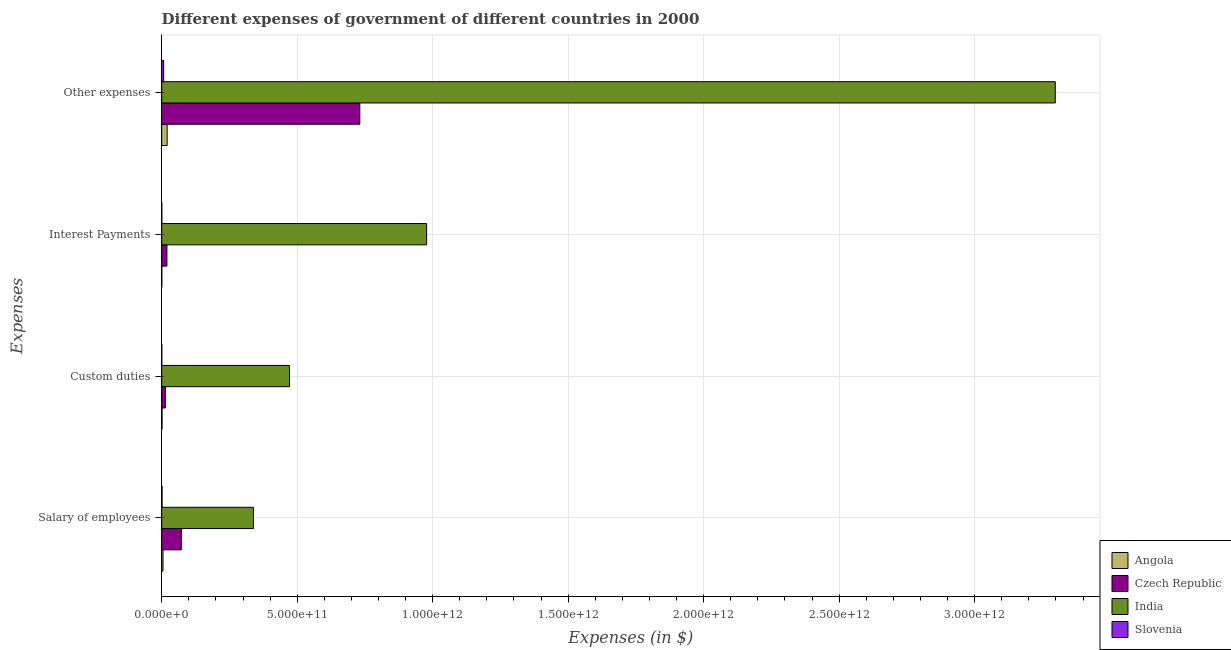How many bars are there on the 2nd tick from the top?
Provide a succinct answer. 4. How many bars are there on the 1st tick from the bottom?
Ensure brevity in your answer.  4. What is the label of the 4th group of bars from the top?
Keep it short and to the point. Salary of employees. What is the amount spent on salary of employees in India?
Provide a succinct answer. 3.39e+11. Across all countries, what is the maximum amount spent on interest payments?
Offer a very short reply. 9.78e+11. Across all countries, what is the minimum amount spent on interest payments?
Provide a succinct answer. 1.75e+08. In which country was the amount spent on salary of employees maximum?
Your response must be concise. India. In which country was the amount spent on salary of employees minimum?
Your answer should be compact. Slovenia. What is the total amount spent on interest payments in the graph?
Your answer should be very brief. 9.97e+11. What is the difference between the amount spent on salary of employees in Slovenia and that in India?
Your response must be concise. -3.37e+11. What is the difference between the amount spent on interest payments in Slovenia and the amount spent on other expenses in Angola?
Your answer should be compact. -1.98e+1. What is the average amount spent on salary of employees per country?
Give a very brief answer. 1.04e+11. What is the difference between the amount spent on interest payments and amount spent on other expenses in Angola?
Your response must be concise. -1.99e+1. In how many countries, is the amount spent on custom duties greater than 1500000000000 $?
Give a very brief answer. 0. What is the ratio of the amount spent on interest payments in Angola to that in India?
Your answer should be very brief. 0. Is the amount spent on custom duties in India less than that in Angola?
Your answer should be very brief. No. Is the difference between the amount spent on custom duties in Czech Republic and Slovenia greater than the difference between the amount spent on interest payments in Czech Republic and Slovenia?
Your answer should be very brief. No. What is the difference between the highest and the second highest amount spent on interest payments?
Provide a short and direct response. 9.59e+11. What is the difference between the highest and the lowest amount spent on interest payments?
Offer a terse response. 9.78e+11. In how many countries, is the amount spent on other expenses greater than the average amount spent on other expenses taken over all countries?
Your response must be concise. 1. Is the sum of the amount spent on salary of employees in Angola and Czech Republic greater than the maximum amount spent on custom duties across all countries?
Make the answer very short. No. What does the 1st bar from the top in Custom duties represents?
Offer a very short reply. Slovenia. What does the 3rd bar from the bottom in Salary of employees represents?
Your response must be concise. India. Is it the case that in every country, the sum of the amount spent on salary of employees and amount spent on custom duties is greater than the amount spent on interest payments?
Your answer should be very brief. No. How many bars are there?
Make the answer very short. 16. How many countries are there in the graph?
Give a very brief answer. 4. What is the difference between two consecutive major ticks on the X-axis?
Give a very brief answer. 5.00e+11. Does the graph contain grids?
Provide a short and direct response. Yes. Where does the legend appear in the graph?
Offer a terse response. Bottom right. What is the title of the graph?
Ensure brevity in your answer.  Different expenses of government of different countries in 2000. What is the label or title of the X-axis?
Make the answer very short. Expenses (in $). What is the label or title of the Y-axis?
Offer a very short reply. Expenses. What is the Expenses (in $) in Angola in Salary of employees?
Provide a short and direct response. 4.77e+09. What is the Expenses (in $) of Czech Republic in Salary of employees?
Offer a terse response. 7.26e+1. What is the Expenses (in $) in India in Salary of employees?
Your response must be concise. 3.39e+11. What is the Expenses (in $) in Slovenia in Salary of employees?
Your response must be concise. 1.30e+09. What is the Expenses (in $) of Angola in Custom duties?
Offer a very short reply. 1.20e+09. What is the Expenses (in $) of Czech Republic in Custom duties?
Offer a very short reply. 1.36e+1. What is the Expenses (in $) in India in Custom duties?
Your answer should be very brief. 4.72e+11. What is the Expenses (in $) in Slovenia in Custom duties?
Offer a terse response. 1.59e+08. What is the Expenses (in $) in Angola in Interest Payments?
Give a very brief answer. 1.75e+08. What is the Expenses (in $) of Czech Republic in Interest Payments?
Make the answer very short. 1.92e+1. What is the Expenses (in $) of India in Interest Payments?
Offer a terse response. 9.78e+11. What is the Expenses (in $) of Slovenia in Interest Payments?
Give a very brief answer. 2.54e+08. What is the Expenses (in $) in Angola in Other expenses?
Your response must be concise. 2.00e+1. What is the Expenses (in $) of Czech Republic in Other expenses?
Give a very brief answer. 7.31e+11. What is the Expenses (in $) of India in Other expenses?
Your response must be concise. 3.30e+12. What is the Expenses (in $) in Slovenia in Other expenses?
Provide a short and direct response. 7.21e+09. Across all Expenses, what is the maximum Expenses (in $) in Angola?
Ensure brevity in your answer.  2.00e+1. Across all Expenses, what is the maximum Expenses (in $) of Czech Republic?
Give a very brief answer. 7.31e+11. Across all Expenses, what is the maximum Expenses (in $) of India?
Make the answer very short. 3.30e+12. Across all Expenses, what is the maximum Expenses (in $) of Slovenia?
Your answer should be very brief. 7.21e+09. Across all Expenses, what is the minimum Expenses (in $) in Angola?
Provide a short and direct response. 1.75e+08. Across all Expenses, what is the minimum Expenses (in $) of Czech Republic?
Make the answer very short. 1.36e+1. Across all Expenses, what is the minimum Expenses (in $) in India?
Provide a short and direct response. 3.39e+11. Across all Expenses, what is the minimum Expenses (in $) in Slovenia?
Offer a terse response. 1.59e+08. What is the total Expenses (in $) in Angola in the graph?
Provide a succinct answer. 2.62e+1. What is the total Expenses (in $) of Czech Republic in the graph?
Your answer should be compact. 8.36e+11. What is the total Expenses (in $) of India in the graph?
Ensure brevity in your answer.  5.09e+12. What is the total Expenses (in $) in Slovenia in the graph?
Your answer should be very brief. 8.92e+09. What is the difference between the Expenses (in $) in Angola in Salary of employees and that in Custom duties?
Provide a short and direct response. 3.57e+09. What is the difference between the Expenses (in $) in Czech Republic in Salary of employees and that in Custom duties?
Ensure brevity in your answer.  5.89e+1. What is the difference between the Expenses (in $) of India in Salary of employees and that in Custom duties?
Your answer should be compact. -1.33e+11. What is the difference between the Expenses (in $) in Slovenia in Salary of employees and that in Custom duties?
Make the answer very short. 1.14e+09. What is the difference between the Expenses (in $) of Angola in Salary of employees and that in Interest Payments?
Your answer should be very brief. 4.60e+09. What is the difference between the Expenses (in $) in Czech Republic in Salary of employees and that in Interest Payments?
Offer a very short reply. 5.34e+1. What is the difference between the Expenses (in $) of India in Salary of employees and that in Interest Payments?
Offer a very short reply. -6.39e+11. What is the difference between the Expenses (in $) of Slovenia in Salary of employees and that in Interest Payments?
Provide a short and direct response. 1.04e+09. What is the difference between the Expenses (in $) of Angola in Salary of employees and that in Other expenses?
Your response must be concise. -1.53e+1. What is the difference between the Expenses (in $) in Czech Republic in Salary of employees and that in Other expenses?
Keep it short and to the point. -6.59e+11. What is the difference between the Expenses (in $) of India in Salary of employees and that in Other expenses?
Offer a very short reply. -2.96e+12. What is the difference between the Expenses (in $) of Slovenia in Salary of employees and that in Other expenses?
Ensure brevity in your answer.  -5.91e+09. What is the difference between the Expenses (in $) in Angola in Custom duties and that in Interest Payments?
Offer a terse response. 1.03e+09. What is the difference between the Expenses (in $) of Czech Republic in Custom duties and that in Interest Payments?
Provide a short and direct response. -5.54e+09. What is the difference between the Expenses (in $) in India in Custom duties and that in Interest Payments?
Offer a very short reply. -5.06e+11. What is the difference between the Expenses (in $) in Slovenia in Custom duties and that in Interest Payments?
Provide a succinct answer. -9.51e+07. What is the difference between the Expenses (in $) of Angola in Custom duties and that in Other expenses?
Your answer should be very brief. -1.88e+1. What is the difference between the Expenses (in $) of Czech Republic in Custom duties and that in Other expenses?
Offer a very short reply. -7.17e+11. What is the difference between the Expenses (in $) of India in Custom duties and that in Other expenses?
Give a very brief answer. -2.83e+12. What is the difference between the Expenses (in $) in Slovenia in Custom duties and that in Other expenses?
Ensure brevity in your answer.  -7.05e+09. What is the difference between the Expenses (in $) of Angola in Interest Payments and that in Other expenses?
Offer a terse response. -1.99e+1. What is the difference between the Expenses (in $) in Czech Republic in Interest Payments and that in Other expenses?
Give a very brief answer. -7.12e+11. What is the difference between the Expenses (in $) of India in Interest Payments and that in Other expenses?
Keep it short and to the point. -2.32e+12. What is the difference between the Expenses (in $) of Slovenia in Interest Payments and that in Other expenses?
Your response must be concise. -6.96e+09. What is the difference between the Expenses (in $) in Angola in Salary of employees and the Expenses (in $) in Czech Republic in Custom duties?
Keep it short and to the point. -8.84e+09. What is the difference between the Expenses (in $) of Angola in Salary of employees and the Expenses (in $) of India in Custom duties?
Your answer should be compact. -4.67e+11. What is the difference between the Expenses (in $) in Angola in Salary of employees and the Expenses (in $) in Slovenia in Custom duties?
Provide a short and direct response. 4.62e+09. What is the difference between the Expenses (in $) in Czech Republic in Salary of employees and the Expenses (in $) in India in Custom duties?
Offer a terse response. -3.99e+11. What is the difference between the Expenses (in $) of Czech Republic in Salary of employees and the Expenses (in $) of Slovenia in Custom duties?
Ensure brevity in your answer.  7.24e+1. What is the difference between the Expenses (in $) in India in Salary of employees and the Expenses (in $) in Slovenia in Custom duties?
Your response must be concise. 3.38e+11. What is the difference between the Expenses (in $) in Angola in Salary of employees and the Expenses (in $) in Czech Republic in Interest Payments?
Ensure brevity in your answer.  -1.44e+1. What is the difference between the Expenses (in $) of Angola in Salary of employees and the Expenses (in $) of India in Interest Payments?
Provide a short and direct response. -9.73e+11. What is the difference between the Expenses (in $) of Angola in Salary of employees and the Expenses (in $) of Slovenia in Interest Payments?
Provide a short and direct response. 4.52e+09. What is the difference between the Expenses (in $) of Czech Republic in Salary of employees and the Expenses (in $) of India in Interest Payments?
Your response must be concise. -9.05e+11. What is the difference between the Expenses (in $) of Czech Republic in Salary of employees and the Expenses (in $) of Slovenia in Interest Payments?
Provide a succinct answer. 7.23e+1. What is the difference between the Expenses (in $) in India in Salary of employees and the Expenses (in $) in Slovenia in Interest Payments?
Give a very brief answer. 3.38e+11. What is the difference between the Expenses (in $) of Angola in Salary of employees and the Expenses (in $) of Czech Republic in Other expenses?
Give a very brief answer. -7.26e+11. What is the difference between the Expenses (in $) of Angola in Salary of employees and the Expenses (in $) of India in Other expenses?
Provide a short and direct response. -3.29e+12. What is the difference between the Expenses (in $) in Angola in Salary of employees and the Expenses (in $) in Slovenia in Other expenses?
Provide a short and direct response. -2.44e+09. What is the difference between the Expenses (in $) in Czech Republic in Salary of employees and the Expenses (in $) in India in Other expenses?
Offer a terse response. -3.23e+12. What is the difference between the Expenses (in $) in Czech Republic in Salary of employees and the Expenses (in $) in Slovenia in Other expenses?
Ensure brevity in your answer.  6.53e+1. What is the difference between the Expenses (in $) in India in Salary of employees and the Expenses (in $) in Slovenia in Other expenses?
Your answer should be compact. 3.31e+11. What is the difference between the Expenses (in $) of Angola in Custom duties and the Expenses (in $) of Czech Republic in Interest Payments?
Keep it short and to the point. -1.79e+1. What is the difference between the Expenses (in $) of Angola in Custom duties and the Expenses (in $) of India in Interest Payments?
Provide a succinct answer. -9.76e+11. What is the difference between the Expenses (in $) in Angola in Custom duties and the Expenses (in $) in Slovenia in Interest Payments?
Offer a terse response. 9.49e+08. What is the difference between the Expenses (in $) of Czech Republic in Custom duties and the Expenses (in $) of India in Interest Payments?
Provide a short and direct response. -9.64e+11. What is the difference between the Expenses (in $) of Czech Republic in Custom duties and the Expenses (in $) of Slovenia in Interest Payments?
Make the answer very short. 1.34e+1. What is the difference between the Expenses (in $) in India in Custom duties and the Expenses (in $) in Slovenia in Interest Payments?
Offer a very short reply. 4.71e+11. What is the difference between the Expenses (in $) of Angola in Custom duties and the Expenses (in $) of Czech Republic in Other expenses?
Give a very brief answer. -7.30e+11. What is the difference between the Expenses (in $) of Angola in Custom duties and the Expenses (in $) of India in Other expenses?
Make the answer very short. -3.30e+12. What is the difference between the Expenses (in $) of Angola in Custom duties and the Expenses (in $) of Slovenia in Other expenses?
Offer a terse response. -6.01e+09. What is the difference between the Expenses (in $) in Czech Republic in Custom duties and the Expenses (in $) in India in Other expenses?
Offer a terse response. -3.28e+12. What is the difference between the Expenses (in $) in Czech Republic in Custom duties and the Expenses (in $) in Slovenia in Other expenses?
Offer a very short reply. 6.40e+09. What is the difference between the Expenses (in $) of India in Custom duties and the Expenses (in $) of Slovenia in Other expenses?
Offer a very short reply. 4.65e+11. What is the difference between the Expenses (in $) in Angola in Interest Payments and the Expenses (in $) in Czech Republic in Other expenses?
Provide a short and direct response. -7.31e+11. What is the difference between the Expenses (in $) in Angola in Interest Payments and the Expenses (in $) in India in Other expenses?
Offer a terse response. -3.30e+12. What is the difference between the Expenses (in $) in Angola in Interest Payments and the Expenses (in $) in Slovenia in Other expenses?
Your answer should be very brief. -7.04e+09. What is the difference between the Expenses (in $) in Czech Republic in Interest Payments and the Expenses (in $) in India in Other expenses?
Your response must be concise. -3.28e+12. What is the difference between the Expenses (in $) of Czech Republic in Interest Payments and the Expenses (in $) of Slovenia in Other expenses?
Offer a terse response. 1.19e+1. What is the difference between the Expenses (in $) of India in Interest Payments and the Expenses (in $) of Slovenia in Other expenses?
Your answer should be compact. 9.70e+11. What is the average Expenses (in $) of Angola per Expenses?
Make the answer very short. 6.55e+09. What is the average Expenses (in $) in Czech Republic per Expenses?
Your answer should be compact. 2.09e+11. What is the average Expenses (in $) in India per Expenses?
Your response must be concise. 1.27e+12. What is the average Expenses (in $) of Slovenia per Expenses?
Keep it short and to the point. 2.23e+09. What is the difference between the Expenses (in $) in Angola and Expenses (in $) in Czech Republic in Salary of employees?
Offer a terse response. -6.78e+1. What is the difference between the Expenses (in $) of Angola and Expenses (in $) of India in Salary of employees?
Keep it short and to the point. -3.34e+11. What is the difference between the Expenses (in $) of Angola and Expenses (in $) of Slovenia in Salary of employees?
Provide a short and direct response. 3.48e+09. What is the difference between the Expenses (in $) in Czech Republic and Expenses (in $) in India in Salary of employees?
Your response must be concise. -2.66e+11. What is the difference between the Expenses (in $) in Czech Republic and Expenses (in $) in Slovenia in Salary of employees?
Ensure brevity in your answer.  7.13e+1. What is the difference between the Expenses (in $) of India and Expenses (in $) of Slovenia in Salary of employees?
Your answer should be very brief. 3.37e+11. What is the difference between the Expenses (in $) in Angola and Expenses (in $) in Czech Republic in Custom duties?
Your answer should be very brief. -1.24e+1. What is the difference between the Expenses (in $) of Angola and Expenses (in $) of India in Custom duties?
Offer a very short reply. -4.71e+11. What is the difference between the Expenses (in $) in Angola and Expenses (in $) in Slovenia in Custom duties?
Your response must be concise. 1.04e+09. What is the difference between the Expenses (in $) of Czech Republic and Expenses (in $) of India in Custom duties?
Provide a succinct answer. -4.58e+11. What is the difference between the Expenses (in $) in Czech Republic and Expenses (in $) in Slovenia in Custom duties?
Provide a short and direct response. 1.35e+1. What is the difference between the Expenses (in $) in India and Expenses (in $) in Slovenia in Custom duties?
Make the answer very short. 4.72e+11. What is the difference between the Expenses (in $) of Angola and Expenses (in $) of Czech Republic in Interest Payments?
Ensure brevity in your answer.  -1.90e+1. What is the difference between the Expenses (in $) in Angola and Expenses (in $) in India in Interest Payments?
Your response must be concise. -9.78e+11. What is the difference between the Expenses (in $) in Angola and Expenses (in $) in Slovenia in Interest Payments?
Give a very brief answer. -7.95e+07. What is the difference between the Expenses (in $) of Czech Republic and Expenses (in $) of India in Interest Payments?
Your answer should be compact. -9.59e+11. What is the difference between the Expenses (in $) of Czech Republic and Expenses (in $) of Slovenia in Interest Payments?
Make the answer very short. 1.89e+1. What is the difference between the Expenses (in $) in India and Expenses (in $) in Slovenia in Interest Payments?
Offer a very short reply. 9.77e+11. What is the difference between the Expenses (in $) of Angola and Expenses (in $) of Czech Republic in Other expenses?
Keep it short and to the point. -7.11e+11. What is the difference between the Expenses (in $) of Angola and Expenses (in $) of India in Other expenses?
Your response must be concise. -3.28e+12. What is the difference between the Expenses (in $) in Angola and Expenses (in $) in Slovenia in Other expenses?
Offer a very short reply. 1.28e+1. What is the difference between the Expenses (in $) in Czech Republic and Expenses (in $) in India in Other expenses?
Keep it short and to the point. -2.57e+12. What is the difference between the Expenses (in $) of Czech Republic and Expenses (in $) of Slovenia in Other expenses?
Provide a succinct answer. 7.24e+11. What is the difference between the Expenses (in $) in India and Expenses (in $) in Slovenia in Other expenses?
Provide a succinct answer. 3.29e+12. What is the ratio of the Expenses (in $) of Angola in Salary of employees to that in Custom duties?
Offer a very short reply. 3.97. What is the ratio of the Expenses (in $) of Czech Republic in Salary of employees to that in Custom duties?
Your response must be concise. 5.33. What is the ratio of the Expenses (in $) in India in Salary of employees to that in Custom duties?
Ensure brevity in your answer.  0.72. What is the ratio of the Expenses (in $) in Slovenia in Salary of employees to that in Custom duties?
Make the answer very short. 8.16. What is the ratio of the Expenses (in $) of Angola in Salary of employees to that in Interest Payments?
Ensure brevity in your answer.  27.35. What is the ratio of the Expenses (in $) in Czech Republic in Salary of employees to that in Interest Payments?
Make the answer very short. 3.79. What is the ratio of the Expenses (in $) of India in Salary of employees to that in Interest Payments?
Offer a terse response. 0.35. What is the ratio of the Expenses (in $) in Slovenia in Salary of employees to that in Interest Payments?
Provide a succinct answer. 5.11. What is the ratio of the Expenses (in $) in Angola in Salary of employees to that in Other expenses?
Offer a very short reply. 0.24. What is the ratio of the Expenses (in $) in Czech Republic in Salary of employees to that in Other expenses?
Your response must be concise. 0.1. What is the ratio of the Expenses (in $) in India in Salary of employees to that in Other expenses?
Keep it short and to the point. 0.1. What is the ratio of the Expenses (in $) of Slovenia in Salary of employees to that in Other expenses?
Your answer should be compact. 0.18. What is the ratio of the Expenses (in $) of Angola in Custom duties to that in Interest Payments?
Provide a short and direct response. 6.89. What is the ratio of the Expenses (in $) of Czech Republic in Custom duties to that in Interest Payments?
Ensure brevity in your answer.  0.71. What is the ratio of the Expenses (in $) in India in Custom duties to that in Interest Payments?
Your answer should be compact. 0.48. What is the ratio of the Expenses (in $) in Slovenia in Custom duties to that in Interest Payments?
Make the answer very short. 0.63. What is the ratio of the Expenses (in $) in Angola in Custom duties to that in Other expenses?
Provide a succinct answer. 0.06. What is the ratio of the Expenses (in $) in Czech Republic in Custom duties to that in Other expenses?
Ensure brevity in your answer.  0.02. What is the ratio of the Expenses (in $) in India in Custom duties to that in Other expenses?
Offer a terse response. 0.14. What is the ratio of the Expenses (in $) in Slovenia in Custom duties to that in Other expenses?
Give a very brief answer. 0.02. What is the ratio of the Expenses (in $) in Angola in Interest Payments to that in Other expenses?
Make the answer very short. 0.01. What is the ratio of the Expenses (in $) in Czech Republic in Interest Payments to that in Other expenses?
Offer a very short reply. 0.03. What is the ratio of the Expenses (in $) of India in Interest Payments to that in Other expenses?
Make the answer very short. 0.3. What is the ratio of the Expenses (in $) of Slovenia in Interest Payments to that in Other expenses?
Provide a short and direct response. 0.04. What is the difference between the highest and the second highest Expenses (in $) in Angola?
Provide a succinct answer. 1.53e+1. What is the difference between the highest and the second highest Expenses (in $) of Czech Republic?
Provide a short and direct response. 6.59e+11. What is the difference between the highest and the second highest Expenses (in $) of India?
Offer a terse response. 2.32e+12. What is the difference between the highest and the second highest Expenses (in $) of Slovenia?
Your answer should be compact. 5.91e+09. What is the difference between the highest and the lowest Expenses (in $) of Angola?
Offer a terse response. 1.99e+1. What is the difference between the highest and the lowest Expenses (in $) in Czech Republic?
Offer a terse response. 7.17e+11. What is the difference between the highest and the lowest Expenses (in $) of India?
Your answer should be compact. 2.96e+12. What is the difference between the highest and the lowest Expenses (in $) of Slovenia?
Provide a succinct answer. 7.05e+09. 